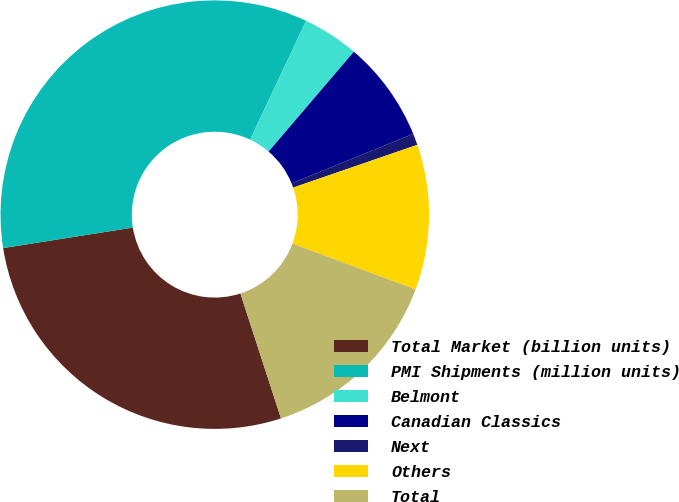Convert chart. <chart><loc_0><loc_0><loc_500><loc_500><pie_chart><fcel>Total Market (billion units)<fcel>PMI Shipments (million units)<fcel>Belmont<fcel>Canadian Classics<fcel>Next<fcel>Others<fcel>Total<nl><fcel>27.51%<fcel>34.5%<fcel>4.24%<fcel>7.6%<fcel>0.87%<fcel>10.96%<fcel>14.32%<nl></chart> 